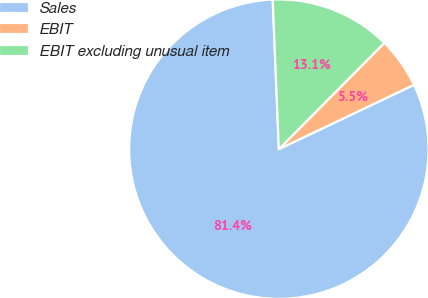Convert chart to OTSL. <chart><loc_0><loc_0><loc_500><loc_500><pie_chart><fcel>Sales<fcel>EBIT<fcel>EBIT excluding unusual item<nl><fcel>81.42%<fcel>5.49%<fcel>13.09%<nl></chart> 